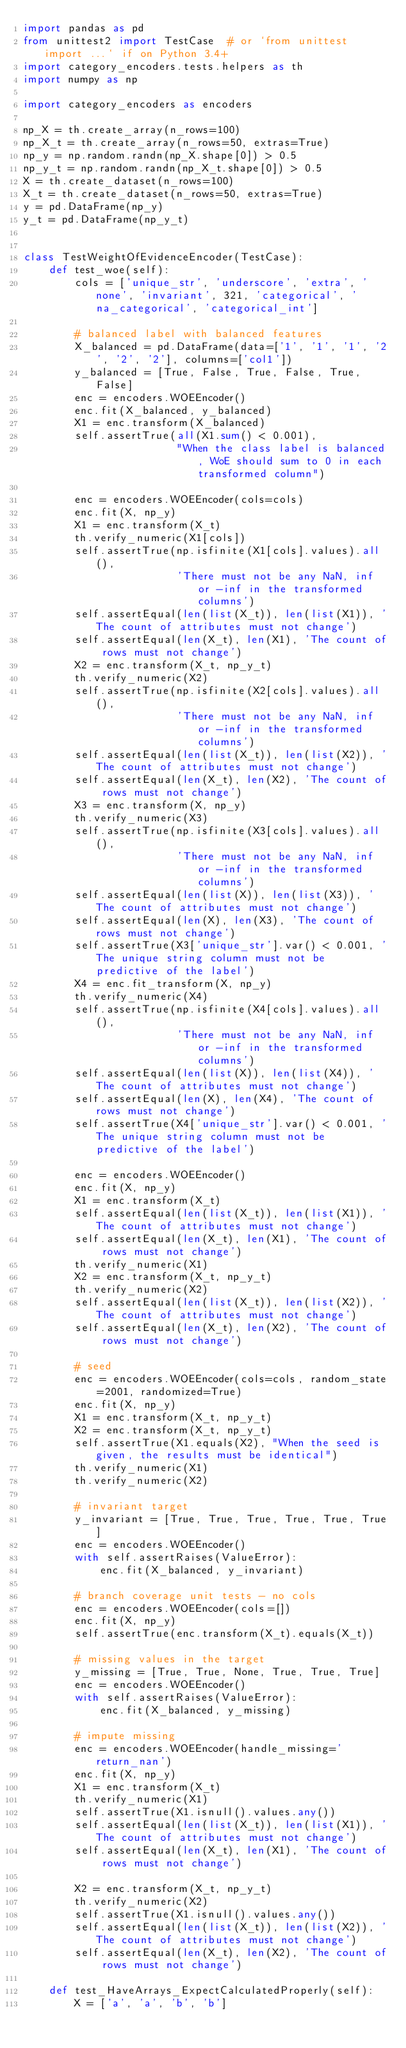<code> <loc_0><loc_0><loc_500><loc_500><_Python_>import pandas as pd
from unittest2 import TestCase  # or `from unittest import ...` if on Python 3.4+
import category_encoders.tests.helpers as th
import numpy as np

import category_encoders as encoders

np_X = th.create_array(n_rows=100)
np_X_t = th.create_array(n_rows=50, extras=True)
np_y = np.random.randn(np_X.shape[0]) > 0.5
np_y_t = np.random.randn(np_X_t.shape[0]) > 0.5
X = th.create_dataset(n_rows=100)
X_t = th.create_dataset(n_rows=50, extras=True)
y = pd.DataFrame(np_y)
y_t = pd.DataFrame(np_y_t)


class TestWeightOfEvidenceEncoder(TestCase):
    def test_woe(self):
        cols = ['unique_str', 'underscore', 'extra', 'none', 'invariant', 321, 'categorical', 'na_categorical', 'categorical_int']

        # balanced label with balanced features
        X_balanced = pd.DataFrame(data=['1', '1', '1', '2', '2', '2'], columns=['col1'])
        y_balanced = [True, False, True, False, True, False]
        enc = encoders.WOEEncoder()
        enc.fit(X_balanced, y_balanced)
        X1 = enc.transform(X_balanced)
        self.assertTrue(all(X1.sum() < 0.001),
                        "When the class label is balanced, WoE should sum to 0 in each transformed column")

        enc = encoders.WOEEncoder(cols=cols)
        enc.fit(X, np_y)
        X1 = enc.transform(X_t)
        th.verify_numeric(X1[cols])
        self.assertTrue(np.isfinite(X1[cols].values).all(),
                        'There must not be any NaN, inf or -inf in the transformed columns')
        self.assertEqual(len(list(X_t)), len(list(X1)), 'The count of attributes must not change')
        self.assertEqual(len(X_t), len(X1), 'The count of rows must not change')
        X2 = enc.transform(X_t, np_y_t)
        th.verify_numeric(X2)
        self.assertTrue(np.isfinite(X2[cols].values).all(),
                        'There must not be any NaN, inf or -inf in the transformed columns')
        self.assertEqual(len(list(X_t)), len(list(X2)), 'The count of attributes must not change')
        self.assertEqual(len(X_t), len(X2), 'The count of rows must not change')
        X3 = enc.transform(X, np_y)
        th.verify_numeric(X3)
        self.assertTrue(np.isfinite(X3[cols].values).all(),
                        'There must not be any NaN, inf or -inf in the transformed columns')
        self.assertEqual(len(list(X)), len(list(X3)), 'The count of attributes must not change')
        self.assertEqual(len(X), len(X3), 'The count of rows must not change')
        self.assertTrue(X3['unique_str'].var() < 0.001, 'The unique string column must not be predictive of the label')
        X4 = enc.fit_transform(X, np_y)
        th.verify_numeric(X4)
        self.assertTrue(np.isfinite(X4[cols].values).all(),
                        'There must not be any NaN, inf or -inf in the transformed columns')
        self.assertEqual(len(list(X)), len(list(X4)), 'The count of attributes must not change')
        self.assertEqual(len(X), len(X4), 'The count of rows must not change')
        self.assertTrue(X4['unique_str'].var() < 0.001, 'The unique string column must not be predictive of the label')

        enc = encoders.WOEEncoder()
        enc.fit(X, np_y)
        X1 = enc.transform(X_t)
        self.assertEqual(len(list(X_t)), len(list(X1)), 'The count of attributes must not change')
        self.assertEqual(len(X_t), len(X1), 'The count of rows must not change')
        th.verify_numeric(X1)
        X2 = enc.transform(X_t, np_y_t)
        th.verify_numeric(X2)
        self.assertEqual(len(list(X_t)), len(list(X2)), 'The count of attributes must not change')
        self.assertEqual(len(X_t), len(X2), 'The count of rows must not change')

        # seed
        enc = encoders.WOEEncoder(cols=cols, random_state=2001, randomized=True)
        enc.fit(X, np_y)
        X1 = enc.transform(X_t, np_y_t)
        X2 = enc.transform(X_t, np_y_t)
        self.assertTrue(X1.equals(X2), "When the seed is given, the results must be identical")
        th.verify_numeric(X1)
        th.verify_numeric(X2)

        # invariant target
        y_invariant = [True, True, True, True, True, True]
        enc = encoders.WOEEncoder()
        with self.assertRaises(ValueError):
            enc.fit(X_balanced, y_invariant)

        # branch coverage unit tests - no cols
        enc = encoders.WOEEncoder(cols=[])
        enc.fit(X, np_y)
        self.assertTrue(enc.transform(X_t).equals(X_t))

        # missing values in the target
        y_missing = [True, True, None, True, True, True]
        enc = encoders.WOEEncoder()
        with self.assertRaises(ValueError):
            enc.fit(X_balanced, y_missing)

        # impute missing
        enc = encoders.WOEEncoder(handle_missing='return_nan')
        enc.fit(X, np_y)
        X1 = enc.transform(X_t)
        th.verify_numeric(X1)
        self.assertTrue(X1.isnull().values.any())
        self.assertEqual(len(list(X_t)), len(list(X1)), 'The count of attributes must not change')
        self.assertEqual(len(X_t), len(X1), 'The count of rows must not change')

        X2 = enc.transform(X_t, np_y_t)
        th.verify_numeric(X2)
        self.assertTrue(X1.isnull().values.any())
        self.assertEqual(len(list(X_t)), len(list(X2)), 'The count of attributes must not change')
        self.assertEqual(len(X_t), len(X2), 'The count of rows must not change')

    def test_HaveArrays_ExpectCalculatedProperly(self):
        X = ['a', 'a', 'b', 'b']</code> 